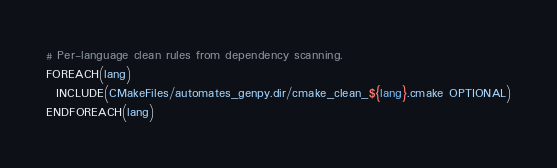Convert code to text. <code><loc_0><loc_0><loc_500><loc_500><_CMake_># Per-language clean rules from dependency scanning.
FOREACH(lang)
  INCLUDE(CMakeFiles/automates_genpy.dir/cmake_clean_${lang}.cmake OPTIONAL)
ENDFOREACH(lang)
</code> 